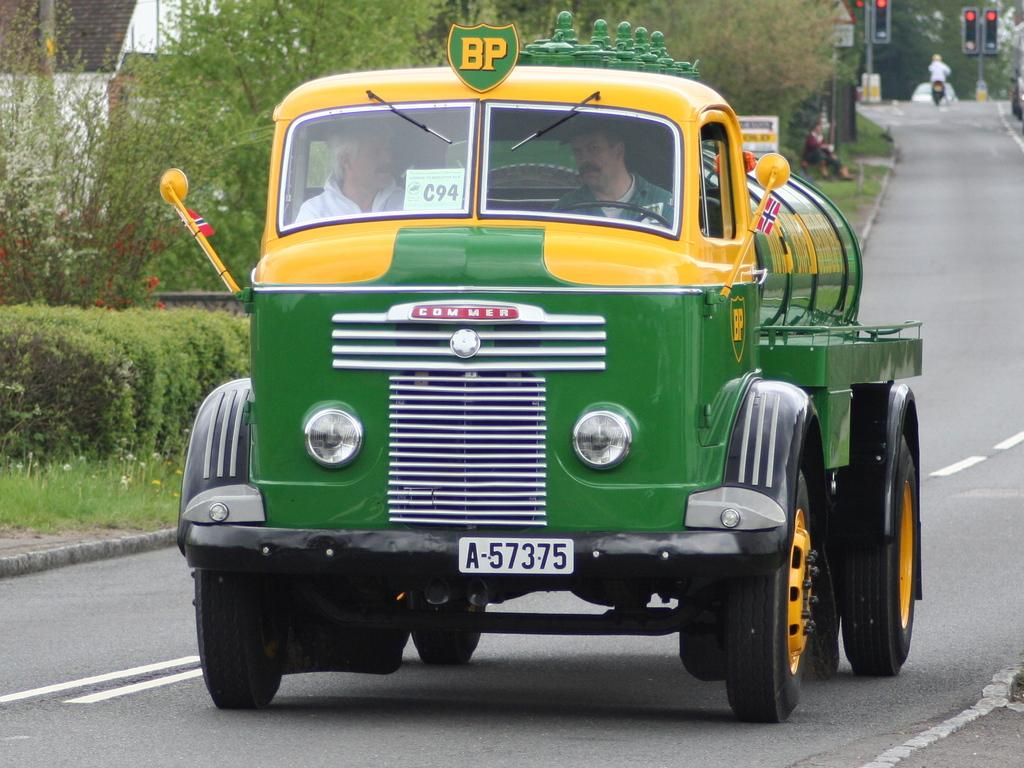Provide a one-sentence caption for the provided image. a green truck that says 'commer' on the front of it. 